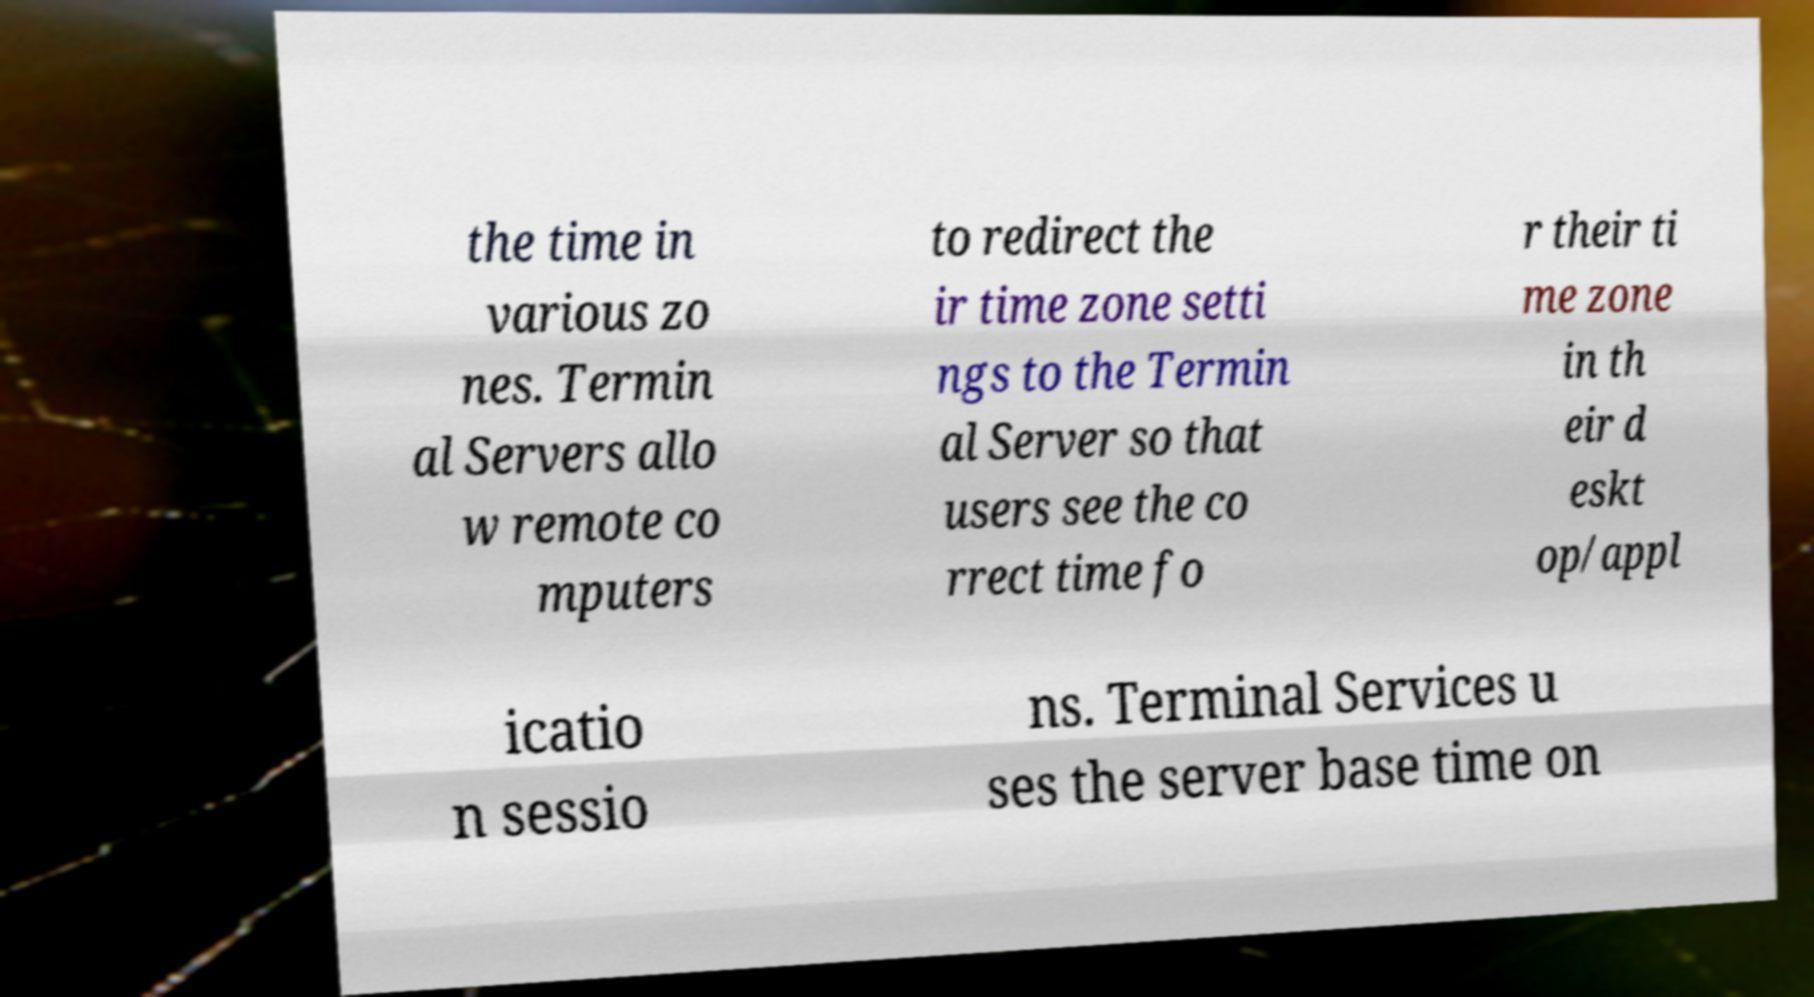There's text embedded in this image that I need extracted. Can you transcribe it verbatim? the time in various zo nes. Termin al Servers allo w remote co mputers to redirect the ir time zone setti ngs to the Termin al Server so that users see the co rrect time fo r their ti me zone in th eir d eskt op/appl icatio n sessio ns. Terminal Services u ses the server base time on 